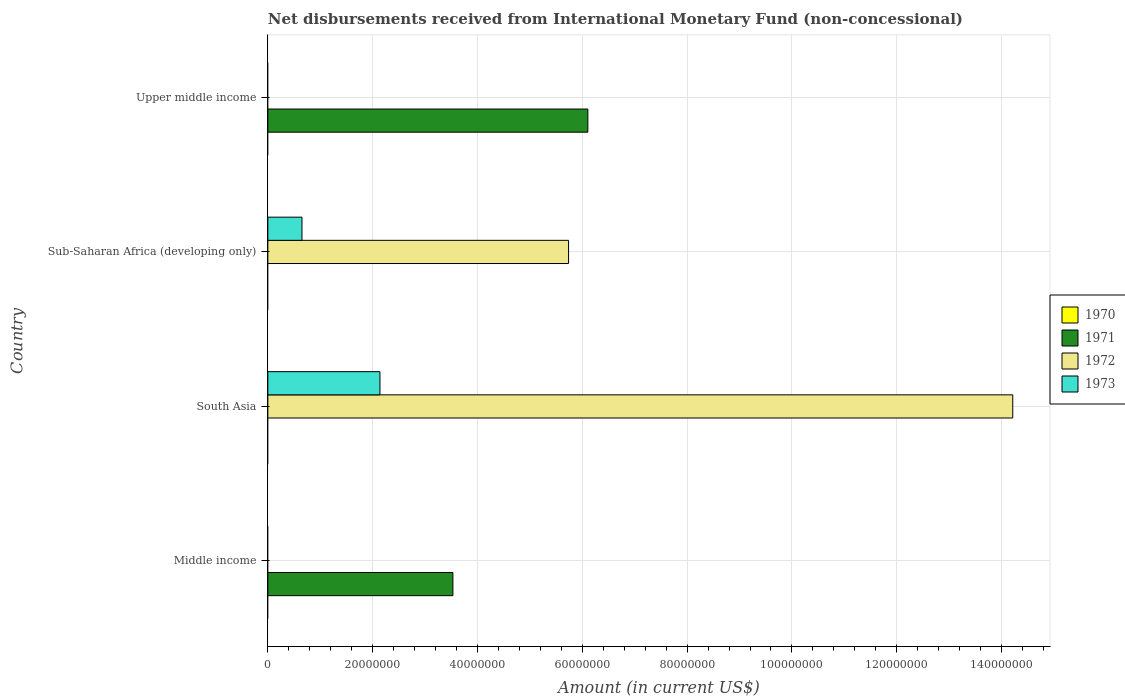Are the number of bars on each tick of the Y-axis equal?
Make the answer very short. No. What is the label of the 2nd group of bars from the top?
Your response must be concise. Sub-Saharan Africa (developing only). In how many cases, is the number of bars for a given country not equal to the number of legend labels?
Offer a very short reply. 4. What is the amount of disbursements received from International Monetary Fund in 1973 in Sub-Saharan Africa (developing only)?
Your answer should be very brief. 6.51e+06. Across all countries, what is the maximum amount of disbursements received from International Monetary Fund in 1972?
Provide a succinct answer. 1.42e+08. What is the total amount of disbursements received from International Monetary Fund in 1971 in the graph?
Your response must be concise. 9.64e+07. What is the difference between the amount of disbursements received from International Monetary Fund in 1973 in South Asia and that in Sub-Saharan Africa (developing only)?
Provide a short and direct response. 1.49e+07. What is the difference between the amount of disbursements received from International Monetary Fund in 1973 in South Asia and the amount of disbursements received from International Monetary Fund in 1970 in Middle income?
Your answer should be very brief. 2.14e+07. What is the average amount of disbursements received from International Monetary Fund in 1972 per country?
Provide a succinct answer. 4.99e+07. What is the difference between the amount of disbursements received from International Monetary Fund in 1972 and amount of disbursements received from International Monetary Fund in 1973 in Sub-Saharan Africa (developing only)?
Offer a terse response. 5.09e+07. In how many countries, is the amount of disbursements received from International Monetary Fund in 1972 greater than 96000000 US$?
Your answer should be very brief. 1. What is the ratio of the amount of disbursements received from International Monetary Fund in 1972 in South Asia to that in Sub-Saharan Africa (developing only)?
Provide a short and direct response. 2.48. Is the difference between the amount of disbursements received from International Monetary Fund in 1972 in South Asia and Sub-Saharan Africa (developing only) greater than the difference between the amount of disbursements received from International Monetary Fund in 1973 in South Asia and Sub-Saharan Africa (developing only)?
Give a very brief answer. Yes. What is the difference between the highest and the lowest amount of disbursements received from International Monetary Fund in 1973?
Make the answer very short. 2.14e+07. Is it the case that in every country, the sum of the amount of disbursements received from International Monetary Fund in 1973 and amount of disbursements received from International Monetary Fund in 1970 is greater than the sum of amount of disbursements received from International Monetary Fund in 1972 and amount of disbursements received from International Monetary Fund in 1971?
Your response must be concise. No. Are all the bars in the graph horizontal?
Your response must be concise. Yes. Are the values on the major ticks of X-axis written in scientific E-notation?
Provide a short and direct response. No. Does the graph contain grids?
Keep it short and to the point. Yes. What is the title of the graph?
Your response must be concise. Net disbursements received from International Monetary Fund (non-concessional). What is the label or title of the Y-axis?
Keep it short and to the point. Country. What is the Amount (in current US$) of 1970 in Middle income?
Keep it short and to the point. 0. What is the Amount (in current US$) of 1971 in Middle income?
Offer a terse response. 3.53e+07. What is the Amount (in current US$) of 1972 in Middle income?
Offer a terse response. 0. What is the Amount (in current US$) in 1973 in Middle income?
Your answer should be compact. 0. What is the Amount (in current US$) in 1971 in South Asia?
Give a very brief answer. 0. What is the Amount (in current US$) in 1972 in South Asia?
Offer a very short reply. 1.42e+08. What is the Amount (in current US$) of 1973 in South Asia?
Offer a terse response. 2.14e+07. What is the Amount (in current US$) of 1971 in Sub-Saharan Africa (developing only)?
Offer a terse response. 0. What is the Amount (in current US$) of 1972 in Sub-Saharan Africa (developing only)?
Offer a very short reply. 5.74e+07. What is the Amount (in current US$) in 1973 in Sub-Saharan Africa (developing only)?
Keep it short and to the point. 6.51e+06. What is the Amount (in current US$) of 1970 in Upper middle income?
Your answer should be very brief. 0. What is the Amount (in current US$) of 1971 in Upper middle income?
Your answer should be very brief. 6.11e+07. What is the Amount (in current US$) in 1972 in Upper middle income?
Make the answer very short. 0. Across all countries, what is the maximum Amount (in current US$) of 1971?
Your answer should be very brief. 6.11e+07. Across all countries, what is the maximum Amount (in current US$) in 1972?
Give a very brief answer. 1.42e+08. Across all countries, what is the maximum Amount (in current US$) of 1973?
Give a very brief answer. 2.14e+07. Across all countries, what is the minimum Amount (in current US$) in 1972?
Make the answer very short. 0. Across all countries, what is the minimum Amount (in current US$) of 1973?
Ensure brevity in your answer.  0. What is the total Amount (in current US$) of 1970 in the graph?
Keep it short and to the point. 0. What is the total Amount (in current US$) in 1971 in the graph?
Provide a succinct answer. 9.64e+07. What is the total Amount (in current US$) of 1972 in the graph?
Your response must be concise. 2.00e+08. What is the total Amount (in current US$) in 1973 in the graph?
Give a very brief answer. 2.79e+07. What is the difference between the Amount (in current US$) of 1971 in Middle income and that in Upper middle income?
Provide a short and direct response. -2.57e+07. What is the difference between the Amount (in current US$) in 1972 in South Asia and that in Sub-Saharan Africa (developing only)?
Give a very brief answer. 8.48e+07. What is the difference between the Amount (in current US$) in 1973 in South Asia and that in Sub-Saharan Africa (developing only)?
Offer a very short reply. 1.49e+07. What is the difference between the Amount (in current US$) in 1971 in Middle income and the Amount (in current US$) in 1972 in South Asia?
Your answer should be very brief. -1.07e+08. What is the difference between the Amount (in current US$) of 1971 in Middle income and the Amount (in current US$) of 1973 in South Asia?
Your answer should be very brief. 1.39e+07. What is the difference between the Amount (in current US$) of 1971 in Middle income and the Amount (in current US$) of 1972 in Sub-Saharan Africa (developing only)?
Offer a very short reply. -2.21e+07. What is the difference between the Amount (in current US$) of 1971 in Middle income and the Amount (in current US$) of 1973 in Sub-Saharan Africa (developing only)?
Keep it short and to the point. 2.88e+07. What is the difference between the Amount (in current US$) of 1972 in South Asia and the Amount (in current US$) of 1973 in Sub-Saharan Africa (developing only)?
Make the answer very short. 1.36e+08. What is the average Amount (in current US$) in 1970 per country?
Your response must be concise. 0. What is the average Amount (in current US$) in 1971 per country?
Provide a succinct answer. 2.41e+07. What is the average Amount (in current US$) in 1972 per country?
Make the answer very short. 4.99e+07. What is the average Amount (in current US$) in 1973 per country?
Your response must be concise. 6.98e+06. What is the difference between the Amount (in current US$) in 1972 and Amount (in current US$) in 1973 in South Asia?
Offer a very short reply. 1.21e+08. What is the difference between the Amount (in current US$) in 1972 and Amount (in current US$) in 1973 in Sub-Saharan Africa (developing only)?
Offer a very short reply. 5.09e+07. What is the ratio of the Amount (in current US$) in 1971 in Middle income to that in Upper middle income?
Your response must be concise. 0.58. What is the ratio of the Amount (in current US$) of 1972 in South Asia to that in Sub-Saharan Africa (developing only)?
Provide a short and direct response. 2.48. What is the ratio of the Amount (in current US$) in 1973 in South Asia to that in Sub-Saharan Africa (developing only)?
Provide a succinct answer. 3.29. What is the difference between the highest and the lowest Amount (in current US$) of 1971?
Give a very brief answer. 6.11e+07. What is the difference between the highest and the lowest Amount (in current US$) in 1972?
Offer a terse response. 1.42e+08. What is the difference between the highest and the lowest Amount (in current US$) in 1973?
Provide a succinct answer. 2.14e+07. 